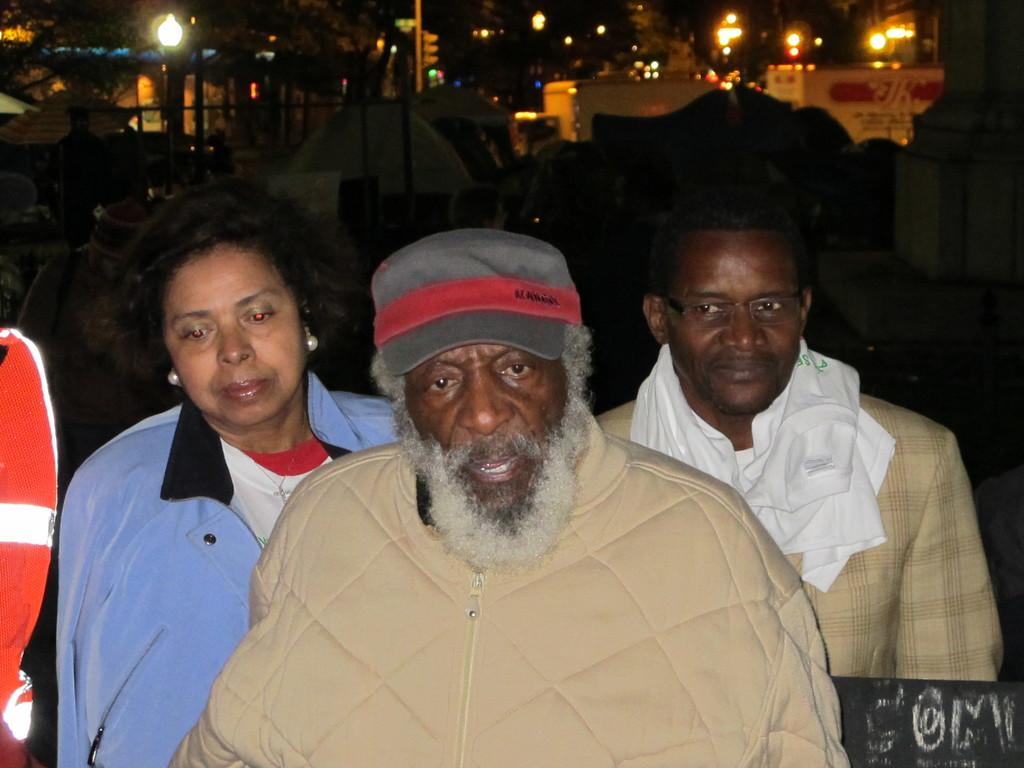How many people are present in the image? There are men and a woman in the image, making a total of three people. What can be seen in the background of the image? Buildings, street poles, street lights, trees, and tents are visible in the background of the image. What type of structures are present in the background? Buildings and tents are present in the background of the image. What type of urban elements can be seen in the background? Street poles and street lights are visible in the background of the image. What type of drawer is visible in the image? There is no drawer present in the image. What is the name of the daughter in the image? There is no daughter mentioned or visible in the image. 